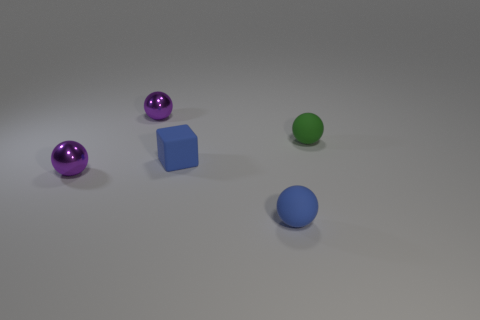The shiny ball behind the green thing is what color? purple 